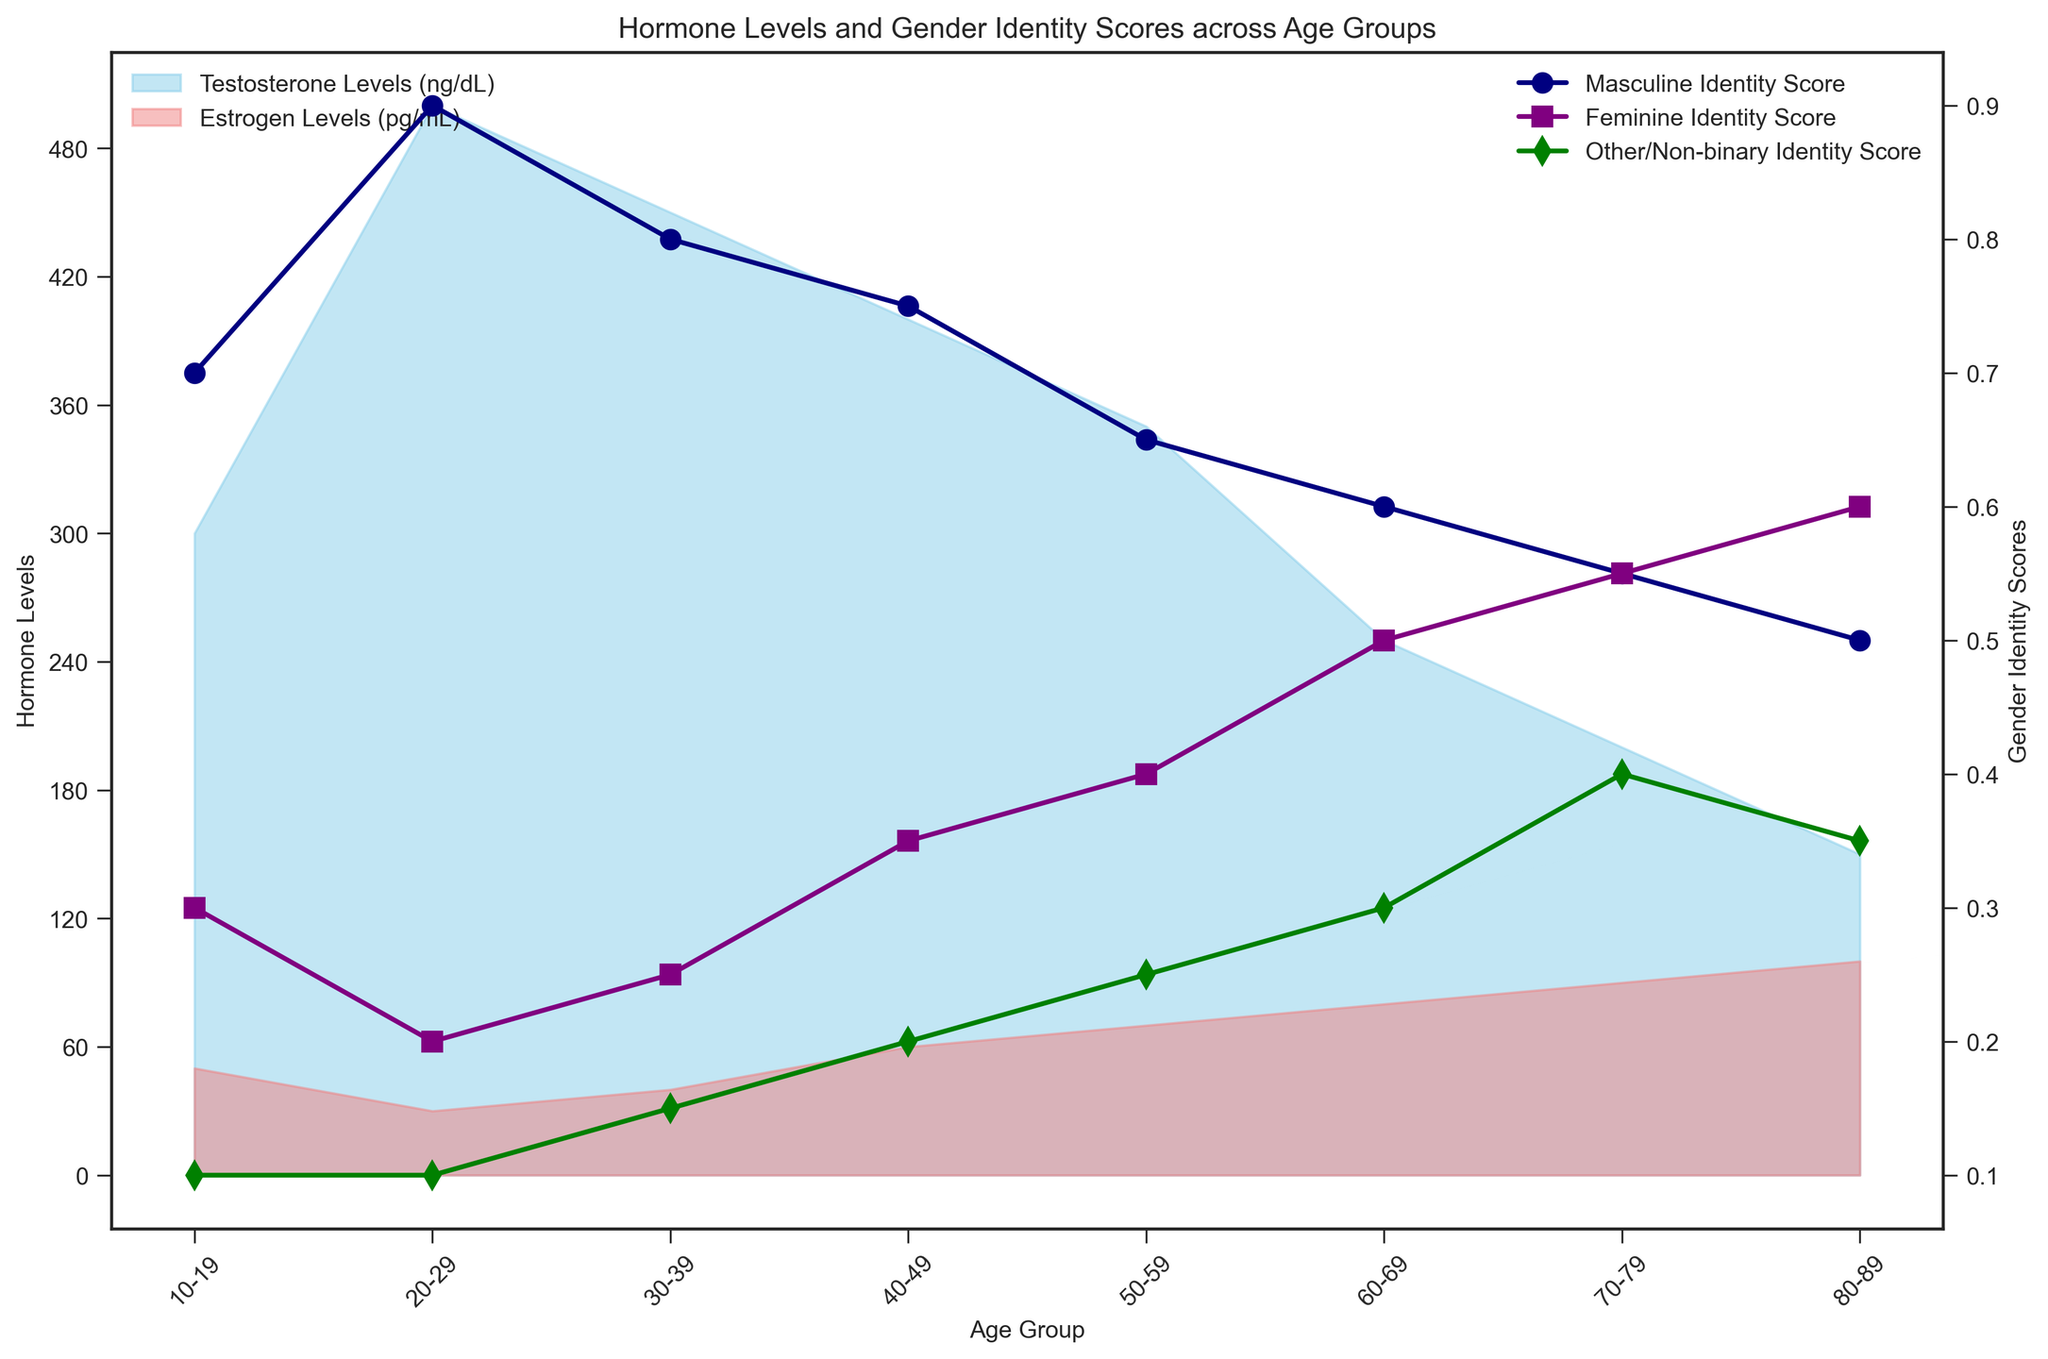Which age group has the highest testosterone levels? The highest point on the skyblue filled area shows the testosterone levels are highest for the 20-29 age group.
Answer: 20-29 Between which two age groups does the feminine gender identity score increase the most? By tracing the purple line, the largest increase in the feminine identity score occurs between the 60-69 and 70-79 age groups.
Answer: 60-69 and 70-79 What is the average testosterone level across all age groups? Summing the testosterone levels for all age groups (300 + 500 + 450 + 400 + 350 + 250 + 200 + 150 = 2600) and dividing by the number of age groups (8) gives 2600/8.
Answer: 325 ng/dL Compare the testosterone and estrogen levels for the 40-49 age group. Which one is higher? For the 40-49 age group, the skyblue area (testosterone) is higher than the lightcoral area (estrogen); testosterone is 400 ng/dL, and estrogen is 60 pg/mL.
Answer: Testosterone Which age group has the lowest masculine gender identity score? Observing the navy blue line, the lowest masculine identity score is at the 80-89 age group.
Answer: 80-89 By how much do the estrogen levels increase from the 20-29 to the 80-89 age group? Estrogen levels increase from 30 pg/mL in the 20-29 age group to 100 pg/mL in the 80-89 age group. The difference is 100 - 30.
Answer: 70 pg/mL Is there a general trend of increasing or decreasing in the other/non-binary identity score with age? Observing the green line, the other/non-binary identity score generally increases with age from 0.1 to 0.4.
Answer: Increasing Compare the hormone levels of the 30-39 and 60-69 age groups. Which age group has higher testosterone levels, and which has higher estrogen levels? The 30-39 age group has higher testosterone levels (450 ng/dL) compared to the 60-69 age group (250 ng/dL). The 60-69 age group has higher estrogen levels (80 pg/mL) compared to the 30-39 age group (40 pg/mL).
Answer: 30-39 (testosterone) and 60-69 (estrogen) What is the difference in the feminine gender identity score between the 50-59 and 70-79 age groups? The feminine identity score for the 50-59 age group is 0.4, and for the 70-79 age group, it is 0.55. The difference is 0.55 - 0.4.
Answer: 0.15 